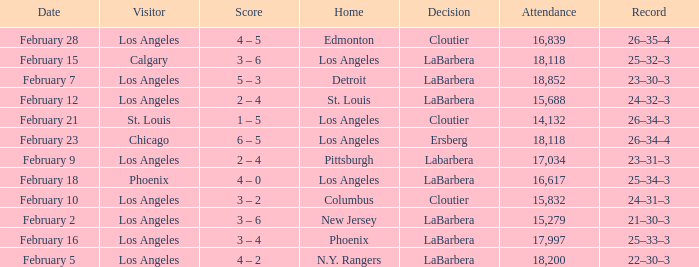What was the decision of the Kings game when Chicago was the visiting team? Ersberg. 